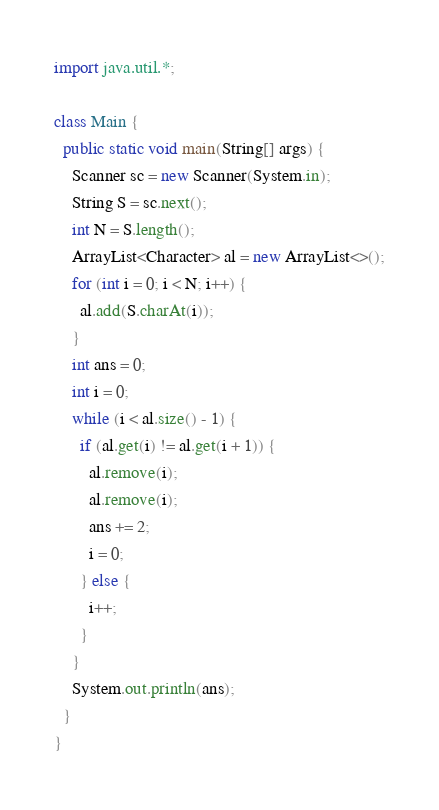Convert code to text. <code><loc_0><loc_0><loc_500><loc_500><_Java_>import java.util.*;

class Main {
  public static void main(String[] args) {
    Scanner sc = new Scanner(System.in);
    String S = sc.next();
    int N = S.length();
    ArrayList<Character> al = new ArrayList<>();
    for (int i = 0; i < N; i++) {
      al.add(S.charAt(i));
    }
    int ans = 0;
    int i = 0;
    while (i < al.size() - 1) {
      if (al.get(i) != al.get(i + 1)) {
        al.remove(i);
        al.remove(i);
        ans += 2;
        i = 0;
      } else {
        i++;
      }
    }
    System.out.println(ans);
  }
}</code> 